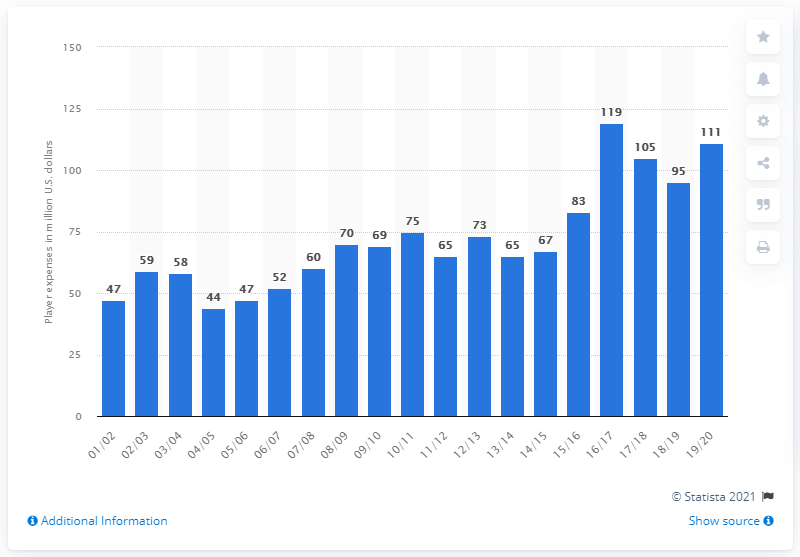List a handful of essential elements in this visual. In the 2019/2020 season, the Atlanta Hawks earned a salary of 111... 